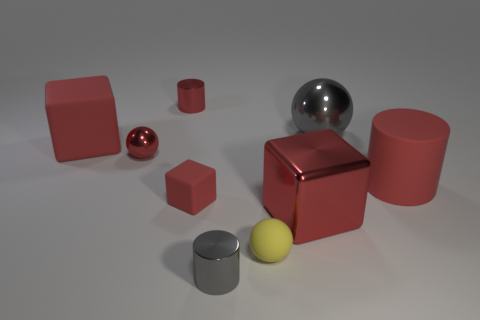What shape is the small red thing that is made of the same material as the small yellow object?
Your response must be concise. Cube. What is the material of the other large thing that is the same shape as the large red metallic thing?
Your answer should be compact. Rubber. Is the number of tiny matte things less than the number of gray shiny cylinders?
Offer a very short reply. No. Are the gray ball and the tiny thing behind the large red matte cube made of the same material?
Provide a succinct answer. Yes. What is the shape of the large red shiny thing in front of the big gray object?
Keep it short and to the point. Cube. Is there any other thing of the same color as the large rubber cube?
Ensure brevity in your answer.  Yes. Are there fewer big blocks behind the big red metallic object than big gray cubes?
Provide a succinct answer. No. How many yellow things have the same size as the yellow rubber ball?
Your response must be concise. 0. What shape is the big rubber object that is the same color as the large rubber block?
Offer a terse response. Cylinder. The big metallic object behind the shiny ball in front of the gray ball to the right of the tiny gray shiny thing is what shape?
Your response must be concise. Sphere. 